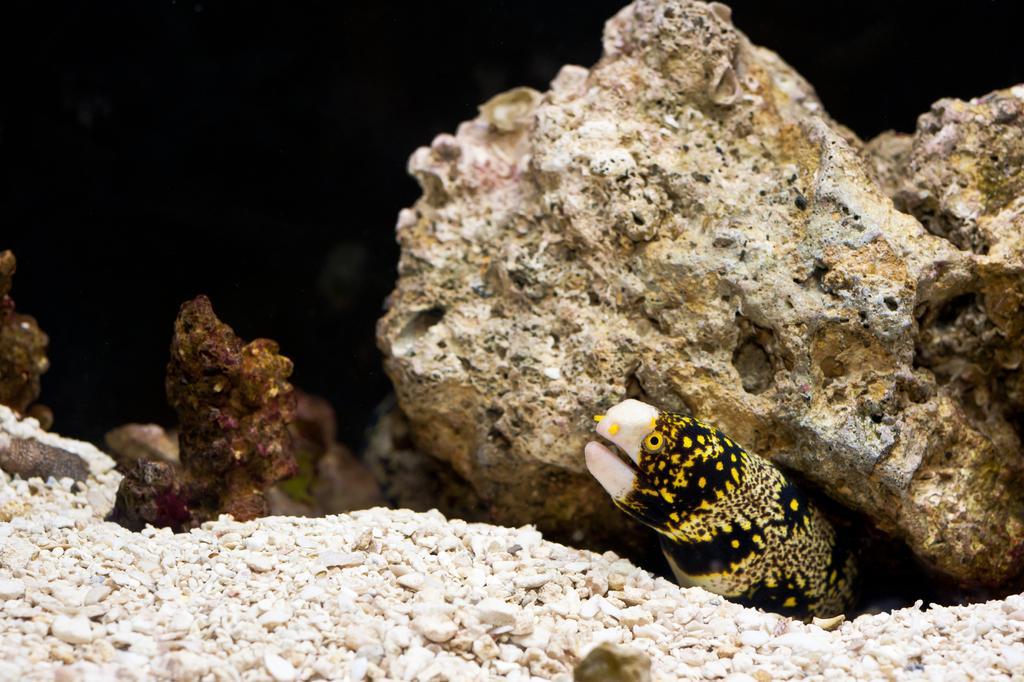Could you give a brief overview of what you see in this image? In this image there is one animal is at bottom of this image and there are some as we can see in middle of this image and bottom of this image as well. 